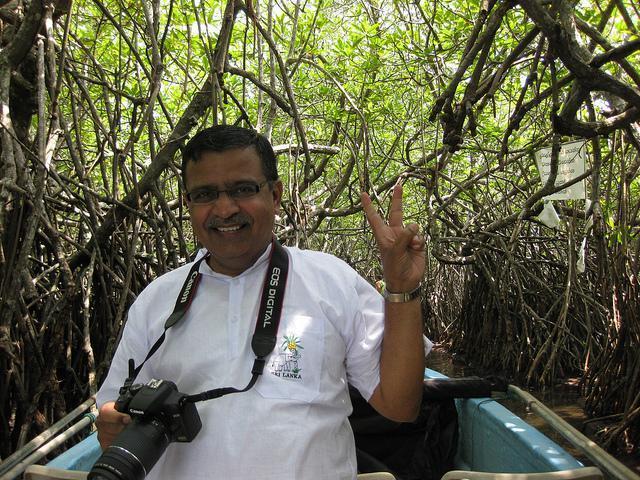Evaluate: Does the caption "The person is in the boat." match the image?
Answer yes or no. Yes. 